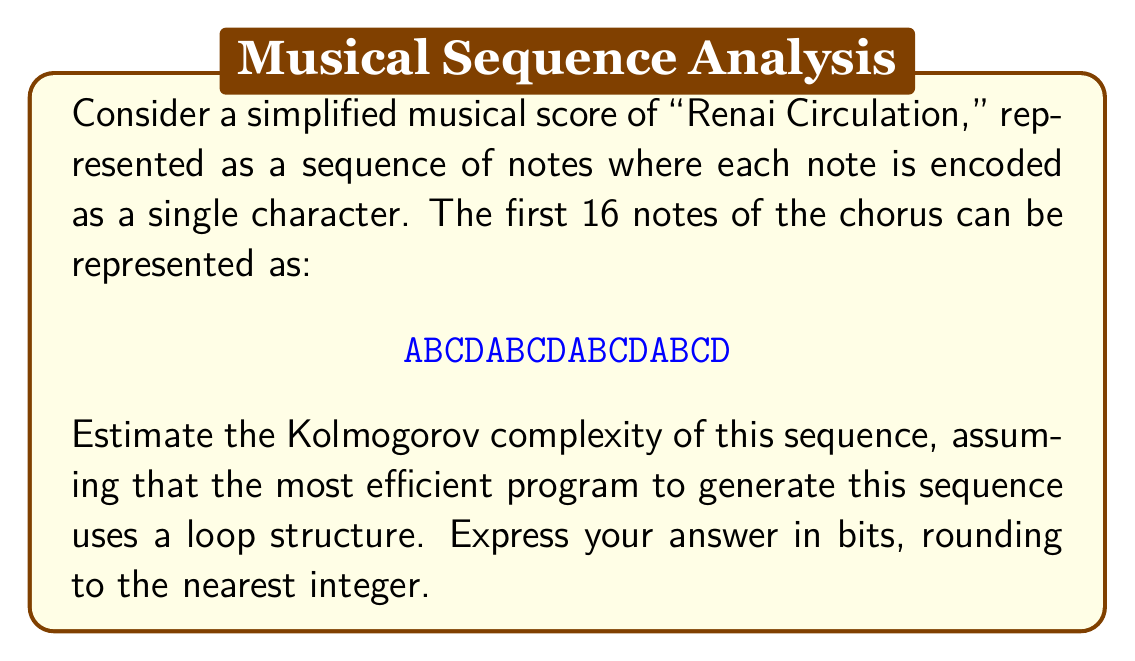Provide a solution to this math problem. To estimate the Kolmogorov complexity of this sequence, we need to consider the most concise program that can generate it. Let's break this down step-by-step:

1) First, we observe that the sequence ABCD repeats 4 times.

2) A simple program to generate this sequence could be structured as follows:
   - Define the string "ABCD"
   - Repeat this string 4 times

3) Let's estimate the bits required for each part of this program:

   a) Defining the string "ABCD":
      - We need 4 characters, each typically requires 8 bits in ASCII encoding
      - 4 * 8 = 32 bits

   b) Loop structure:
      - We need to specify the number of iterations (4)
      - This can be done in about 3 bits (as 4 = 100 in binary)
      - The loop structure itself (like "repeat" keyword) might take about 8 bits

   c) Additional overhead:
      - For variable declarations, operation codes, etc., let's estimate about 16 bits

4) Total estimated bits:
   $$ 32 + 3 + 8 + 16 = 59 \text{ bits} $$

5) Rounding to the nearest integer, we get 59 bits.

This estimate represents the Kolmogorov complexity of the sequence, as it's the length of the shortest program that can produce the given sequence.
Answer: 59 bits 